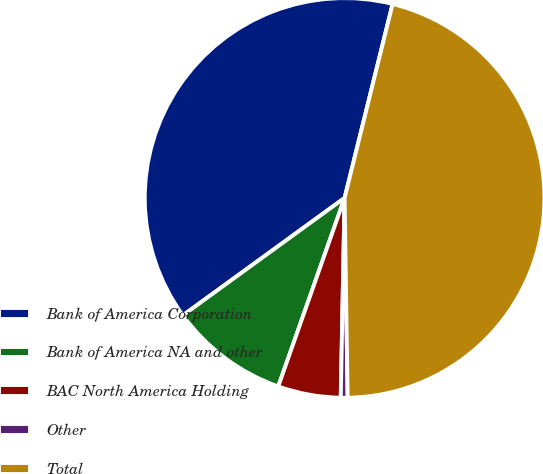Convert chart. <chart><loc_0><loc_0><loc_500><loc_500><pie_chart><fcel>Bank of America Corporation<fcel>Bank of America NA and other<fcel>BAC North America Holding<fcel>Other<fcel>Total<nl><fcel>38.86%<fcel>9.62%<fcel>5.08%<fcel>0.55%<fcel>45.9%<nl></chart> 